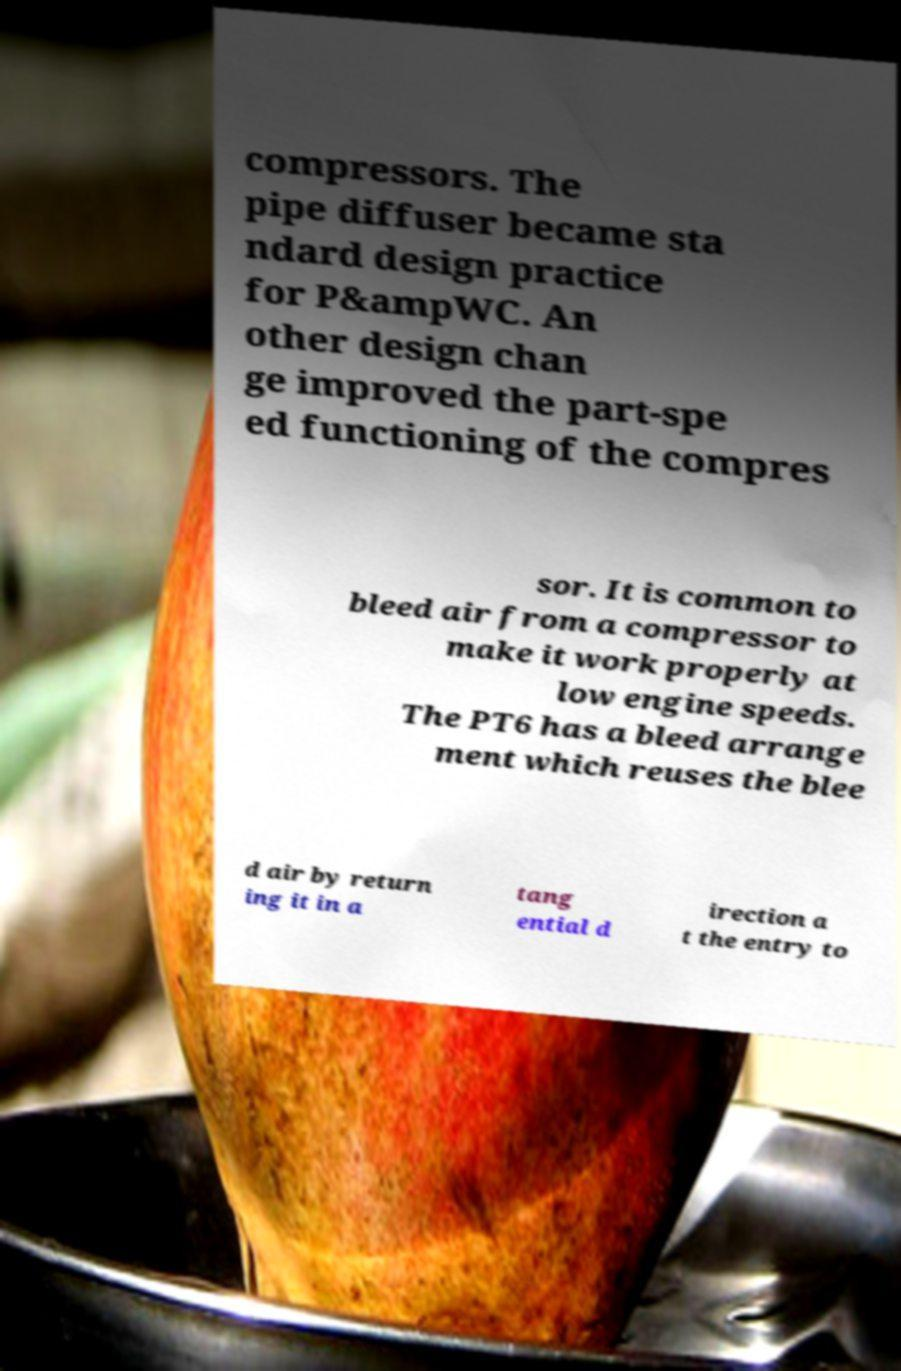There's text embedded in this image that I need extracted. Can you transcribe it verbatim? compressors. The pipe diffuser became sta ndard design practice for P&ampWC. An other design chan ge improved the part-spe ed functioning of the compres sor. It is common to bleed air from a compressor to make it work properly at low engine speeds. The PT6 has a bleed arrange ment which reuses the blee d air by return ing it in a tang ential d irection a t the entry to 